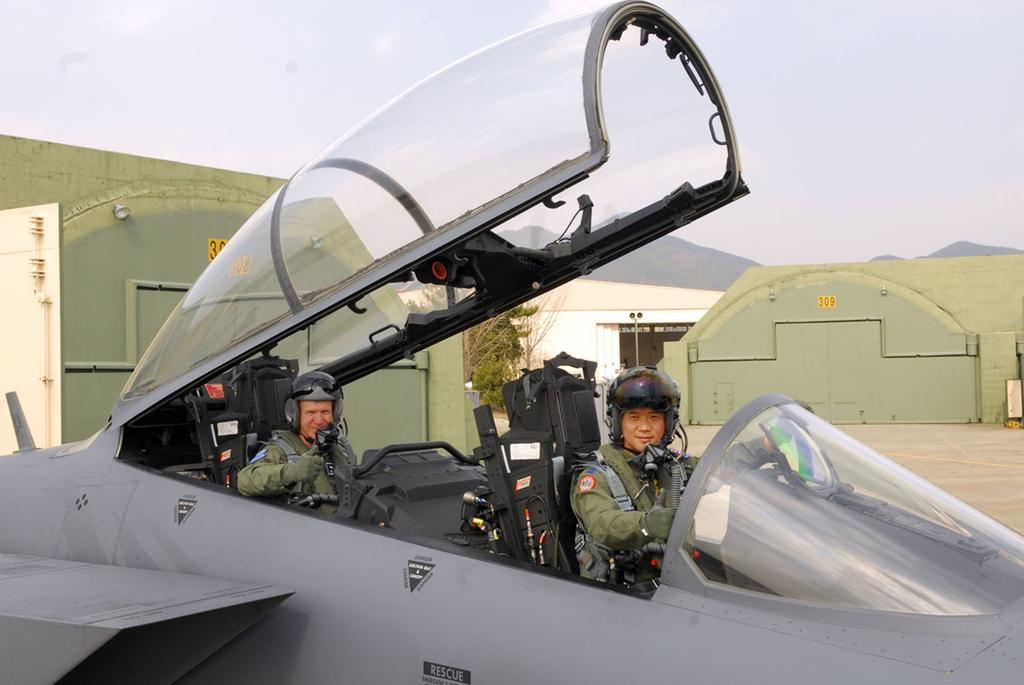<image>
Offer a succinct explanation of the picture presented. Two pilots sit in the open cockpit of a rescue plane. 